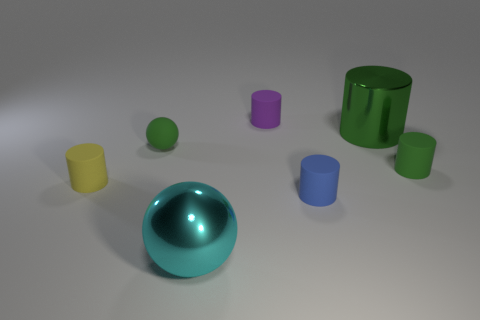Subtract all blue cylinders. How many cylinders are left? 4 Add 1 spheres. How many objects exist? 8 Subtract all purple blocks. How many green cylinders are left? 2 Subtract 1 balls. How many balls are left? 1 Subtract all purple cylinders. How many cylinders are left? 4 Subtract all purple cylinders. Subtract all blue balls. How many cylinders are left? 4 Subtract all large green shiny cylinders. Subtract all tiny brown cubes. How many objects are left? 6 Add 5 large metallic objects. How many large metallic objects are left? 7 Add 5 brown cubes. How many brown cubes exist? 5 Subtract 1 cyan spheres. How many objects are left? 6 